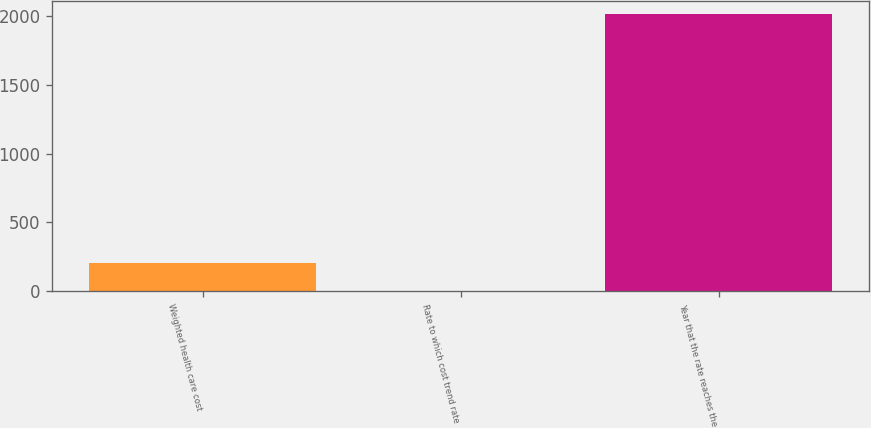Convert chart to OTSL. <chart><loc_0><loc_0><loc_500><loc_500><bar_chart><fcel>Weighted health care cost<fcel>Rate to which cost trend rate<fcel>Year that the rate reaches the<nl><fcel>205.8<fcel>5<fcel>2013<nl></chart> 